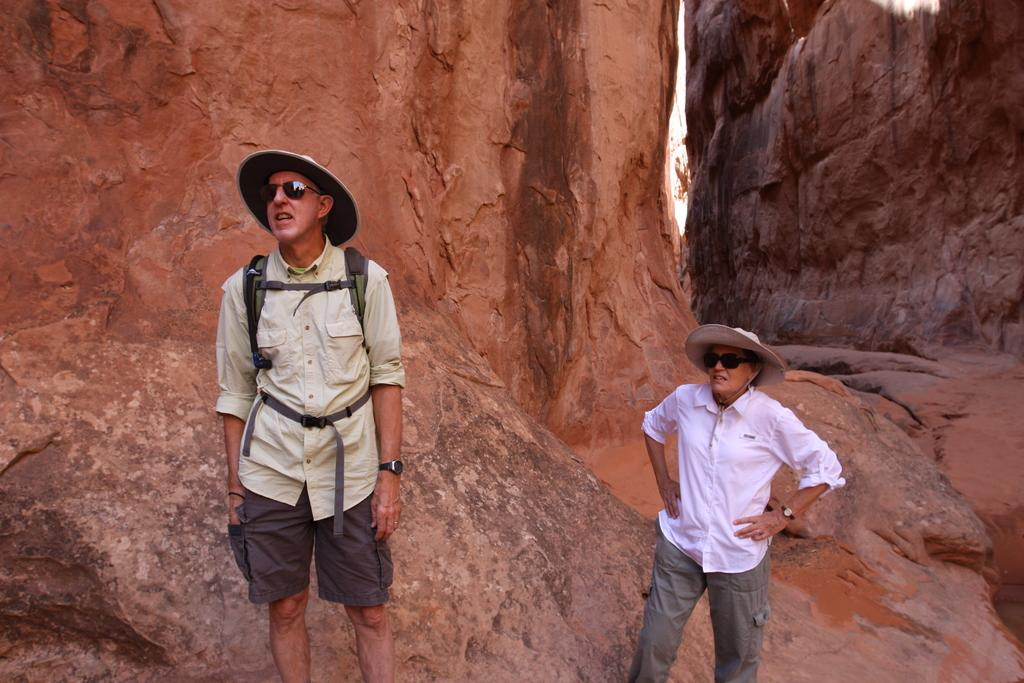Who are the people in the image? There is a woman and a man in the image. Where are the woman and man located in the image? They are in the center of the image. What is the surface they are standing on? They are on a rock. What type of flock can be seen flying over the woman and man in the image? There is no flock visible in the image; it only features a woman and a man standing on a rock. 